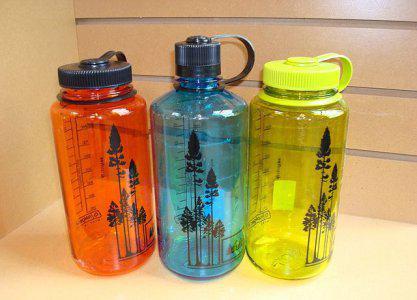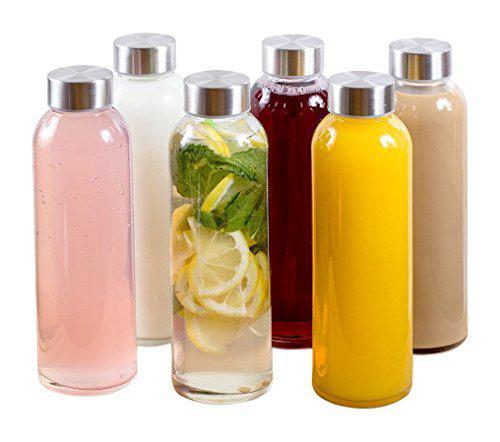The first image is the image on the left, the second image is the image on the right. Assess this claim about the two images: "At least one container contains some slices of fruit in it.". Correct or not? Answer yes or no. Yes. 